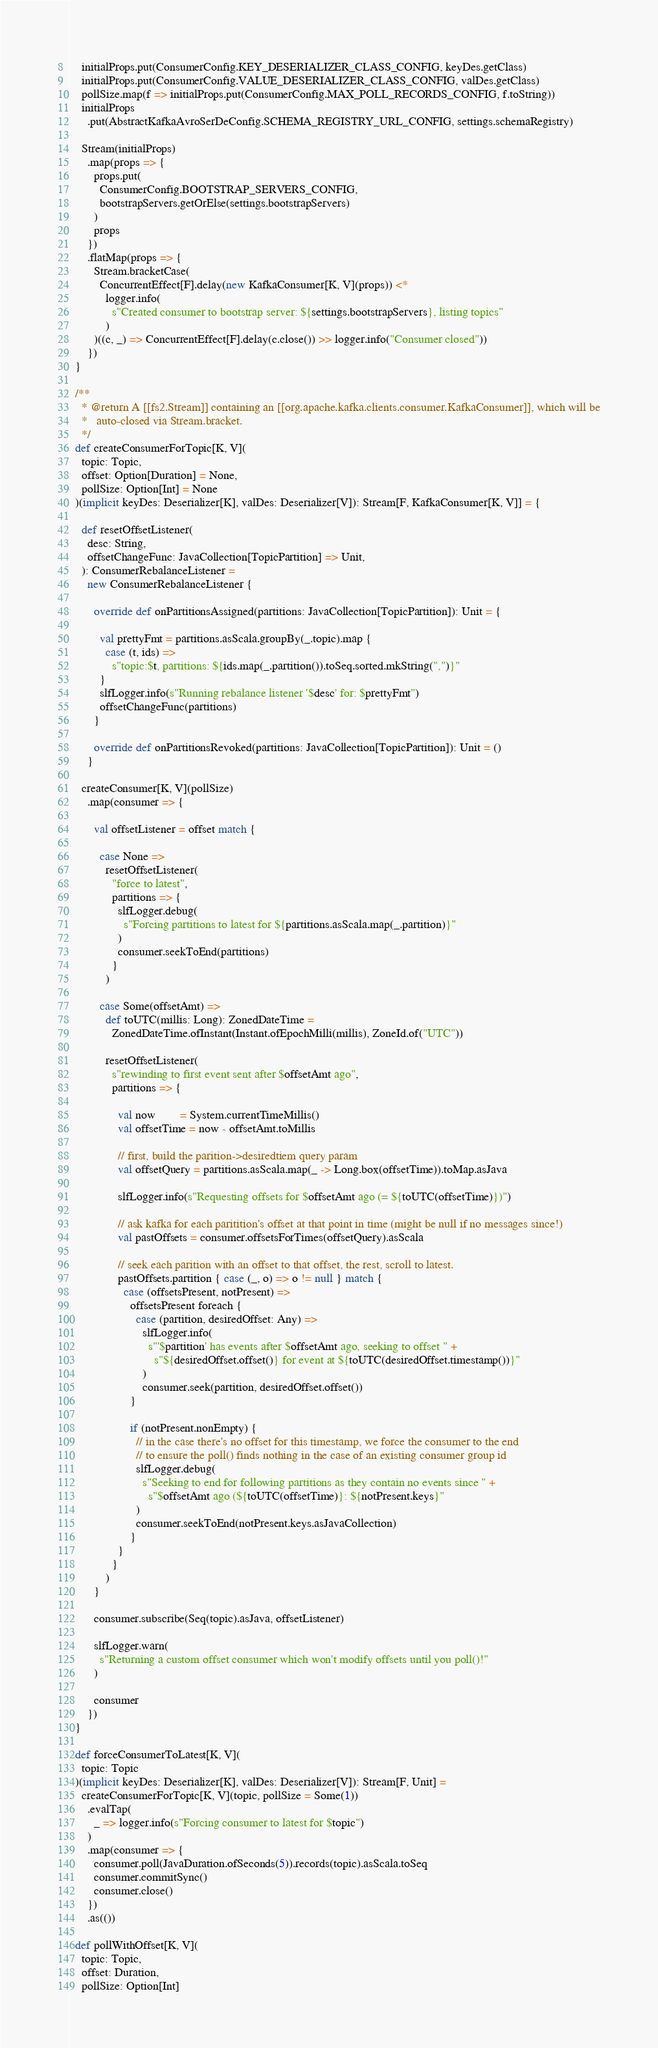Convert code to text. <code><loc_0><loc_0><loc_500><loc_500><_Scala_>    initialProps.put(ConsumerConfig.KEY_DESERIALIZER_CLASS_CONFIG, keyDes.getClass)
    initialProps.put(ConsumerConfig.VALUE_DESERIALIZER_CLASS_CONFIG, valDes.getClass)
    pollSize.map(f => initialProps.put(ConsumerConfig.MAX_POLL_RECORDS_CONFIG, f.toString))
    initialProps
      .put(AbstractKafkaAvroSerDeConfig.SCHEMA_REGISTRY_URL_CONFIG, settings.schemaRegistry)

    Stream(initialProps)
      .map(props => {
        props.put(
          ConsumerConfig.BOOTSTRAP_SERVERS_CONFIG,
          bootstrapServers.getOrElse(settings.bootstrapServers)
        )
        props
      })
      .flatMap(props => {
        Stream.bracketCase(
          ConcurrentEffect[F].delay(new KafkaConsumer[K, V](props)) <*
            logger.info(
              s"Created consumer to bootstrap server: ${settings.bootstrapServers}, listing topics"
            )
        )((c, _) => ConcurrentEffect[F].delay(c.close()) >> logger.info("Consumer closed"))
      })
  }

  /**
    * @return A [[fs2.Stream]] containing an [[org.apache.kafka.clients.consumer.KafkaConsumer]], which will be
    *   auto-closed via Stream.bracket.
    */
  def createConsumerForTopic[K, V](
    topic: Topic,
    offset: Option[Duration] = None,
    pollSize: Option[Int] = None
  )(implicit keyDes: Deserializer[K], valDes: Deserializer[V]): Stream[F, KafkaConsumer[K, V]] = {

    def resetOffsetListener(
      desc: String,
      offsetChangeFunc: JavaCollection[TopicPartition] => Unit,
    ): ConsumerRebalanceListener =
      new ConsumerRebalanceListener {

        override def onPartitionsAssigned(partitions: JavaCollection[TopicPartition]): Unit = {

          val prettyFmt = partitions.asScala.groupBy(_.topic).map {
            case (t, ids) =>
              s"topic:$t, partitions: ${ids.map(_.partition()).toSeq.sorted.mkString(",")}"
          }
          slfLogger.info(s"Running rebalance listener '$desc' for: $prettyFmt")
          offsetChangeFunc(partitions)
        }

        override def onPartitionsRevoked(partitions: JavaCollection[TopicPartition]): Unit = ()
      }

    createConsumer[K, V](pollSize)
      .map(consumer => {

        val offsetListener = offset match {

          case None =>
            resetOffsetListener(
              "force to latest",
              partitions => {
                slfLogger.debug(
                  s"Forcing partitions to latest for ${partitions.asScala.map(_.partition)}"
                )
                consumer.seekToEnd(partitions)
              }
            )

          case Some(offsetAmt) =>
            def toUTC(millis: Long): ZonedDateTime =
              ZonedDateTime.ofInstant(Instant.ofEpochMilli(millis), ZoneId.of("UTC"))

            resetOffsetListener(
              s"rewinding to first event sent after $offsetAmt ago",
              partitions => {

                val now        = System.currentTimeMillis()
                val offsetTime = now - offsetAmt.toMillis

                // first, build the parition->desiredtiem query param
                val offsetQuery = partitions.asScala.map(_ -> Long.box(offsetTime)).toMap.asJava

                slfLogger.info(s"Requesting offsets for $offsetAmt ago (= ${toUTC(offsetTime)})")

                // ask kafka for each paritition's offset at that point in time (might be null if no messages since!)
                val pastOffsets = consumer.offsetsForTimes(offsetQuery).asScala

                // seek each parition with an offset to that offset, the rest, scroll to latest.
                pastOffsets.partition { case (_, o) => o != null } match {
                  case (offsetsPresent, notPresent) =>
                    offsetsPresent foreach {
                      case (partition, desiredOffset: Any) =>
                        slfLogger.info(
                          s"'$partition' has events after $offsetAmt ago, seeking to offset " +
                            s"${desiredOffset.offset()} for event at ${toUTC(desiredOffset.timestamp())}"
                        )
                        consumer.seek(partition, desiredOffset.offset())
                    }

                    if (notPresent.nonEmpty) {
                      // in the case there's no offset for this timestamp, we force the consumer to the end
                      // to ensure the poll() finds nothing in the case of an existing consumer group id
                      slfLogger.debug(
                        s"Seeking to end for following partitions as they contain no events since " +
                          s"$offsetAmt ago (${toUTC(offsetTime)}: ${notPresent.keys}"
                      )
                      consumer.seekToEnd(notPresent.keys.asJavaCollection)
                    }
                }
              }
            )
        }

        consumer.subscribe(Seq(topic).asJava, offsetListener)

        slfLogger.warn(
          s"Returning a custom offset consumer which won't modify offsets until you poll()!"
        )

        consumer
      })
  }

  def forceConsumerToLatest[K, V](
    topic: Topic
  )(implicit keyDes: Deserializer[K], valDes: Deserializer[V]): Stream[F, Unit] =
    createConsumerForTopic[K, V](topic, pollSize = Some(1))
      .evalTap(
        _ => logger.info(s"Forcing consumer to latest for $topic")
      )
      .map(consumer => {
        consumer.poll(JavaDuration.ofSeconds(5)).records(topic).asScala.toSeq
        consumer.commitSync()
        consumer.close()
      })
      .as(())

  def pollWithOffset[K, V](
    topic: Topic,
    offset: Duration,
    pollSize: Option[Int]</code> 